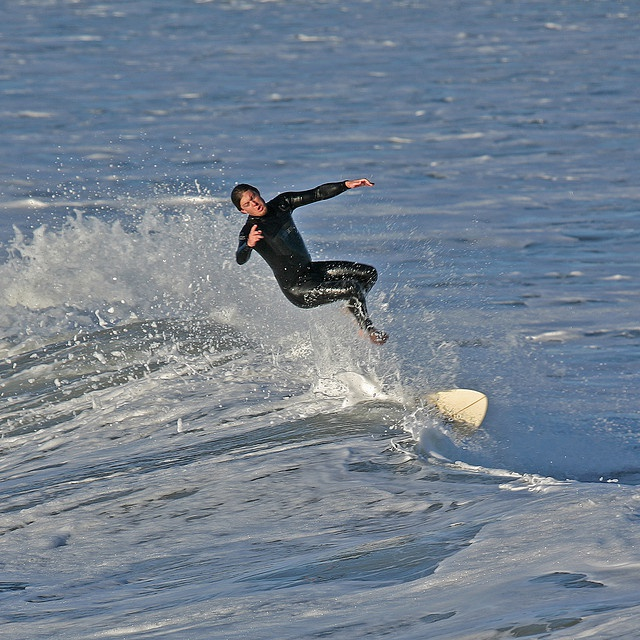Describe the objects in this image and their specific colors. I can see people in gray, black, and darkgray tones and surfboard in gray, tan, and beige tones in this image. 